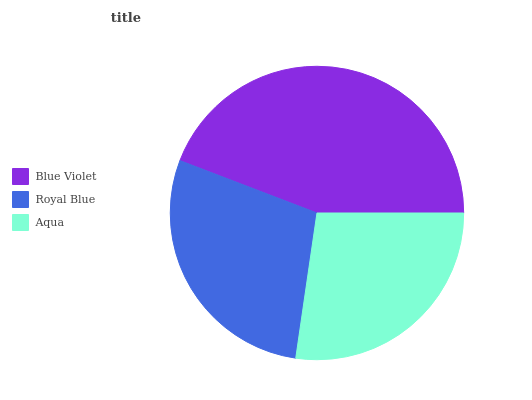Is Aqua the minimum?
Answer yes or no. Yes. Is Blue Violet the maximum?
Answer yes or no. Yes. Is Royal Blue the minimum?
Answer yes or no. No. Is Royal Blue the maximum?
Answer yes or no. No. Is Blue Violet greater than Royal Blue?
Answer yes or no. Yes. Is Royal Blue less than Blue Violet?
Answer yes or no. Yes. Is Royal Blue greater than Blue Violet?
Answer yes or no. No. Is Blue Violet less than Royal Blue?
Answer yes or no. No. Is Royal Blue the high median?
Answer yes or no. Yes. Is Royal Blue the low median?
Answer yes or no. Yes. Is Blue Violet the high median?
Answer yes or no. No. Is Aqua the low median?
Answer yes or no. No. 